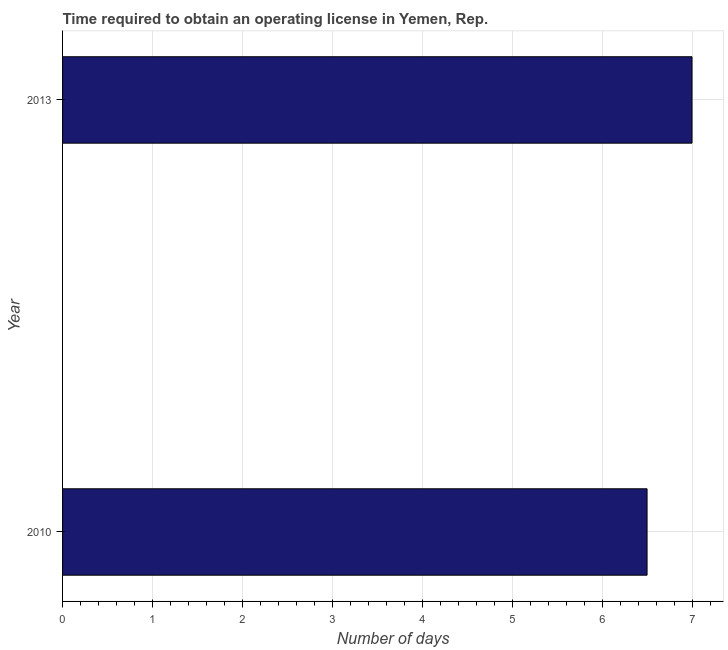What is the title of the graph?
Your answer should be compact. Time required to obtain an operating license in Yemen, Rep. What is the label or title of the X-axis?
Offer a very short reply. Number of days. What is the label or title of the Y-axis?
Make the answer very short. Year. What is the number of days to obtain operating license in 2010?
Provide a succinct answer. 6.5. Across all years, what is the maximum number of days to obtain operating license?
Ensure brevity in your answer.  7. In which year was the number of days to obtain operating license minimum?
Give a very brief answer. 2010. What is the difference between the number of days to obtain operating license in 2010 and 2013?
Keep it short and to the point. -0.5. What is the average number of days to obtain operating license per year?
Your answer should be very brief. 6.75. What is the median number of days to obtain operating license?
Offer a very short reply. 6.75. In how many years, is the number of days to obtain operating license greater than 1.6 days?
Provide a short and direct response. 2. Do a majority of the years between 2010 and 2013 (inclusive) have number of days to obtain operating license greater than 4.6 days?
Offer a very short reply. Yes. What is the ratio of the number of days to obtain operating license in 2010 to that in 2013?
Provide a succinct answer. 0.93. Is the number of days to obtain operating license in 2010 less than that in 2013?
Give a very brief answer. Yes. In how many years, is the number of days to obtain operating license greater than the average number of days to obtain operating license taken over all years?
Give a very brief answer. 1. How many bars are there?
Ensure brevity in your answer.  2. How many years are there in the graph?
Offer a terse response. 2. Are the values on the major ticks of X-axis written in scientific E-notation?
Offer a terse response. No. What is the Number of days of 2013?
Your answer should be very brief. 7. What is the difference between the Number of days in 2010 and 2013?
Make the answer very short. -0.5. What is the ratio of the Number of days in 2010 to that in 2013?
Provide a short and direct response. 0.93. 